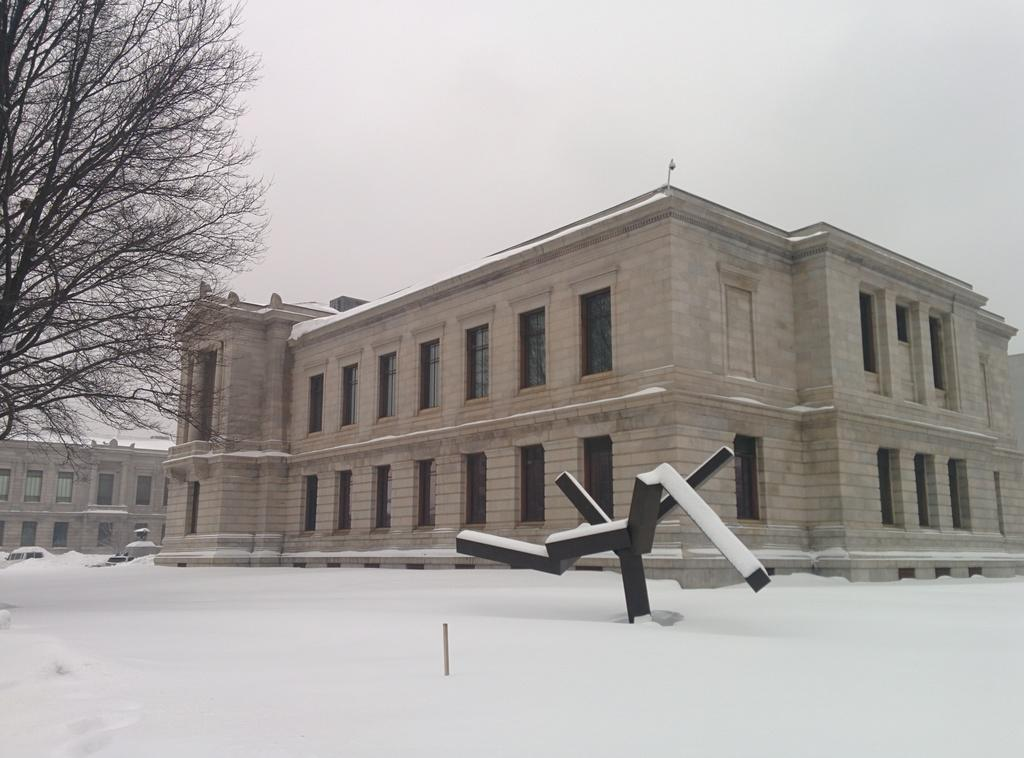What is the main feature of the foreground in the image? There is a lot of snow in the foreground of the image. What structures can be seen behind the snow? There are two buildings visible behind the snow. Is there any vegetation present in the image? Yes, there is a tree on the left side of the image. Where is the cactus located in the image? There is no cactus present in the image. What type of office can be seen in the background of the image? There is no office visible in the image; only two buildings and a tree are present. 